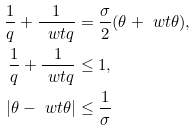<formula> <loc_0><loc_0><loc_500><loc_500>\frac { 1 } { q } + \frac { 1 } { \ w t { q } } & = \frac { \sigma } { 2 } ( \theta + \ w t { \theta } ) , \\ \frac { 1 } { q } + \frac { 1 } { \ w t { q } } & \leq 1 , \\ | \theta - \ w t { \theta } | & \leq \frac { 1 } { \sigma }</formula> 